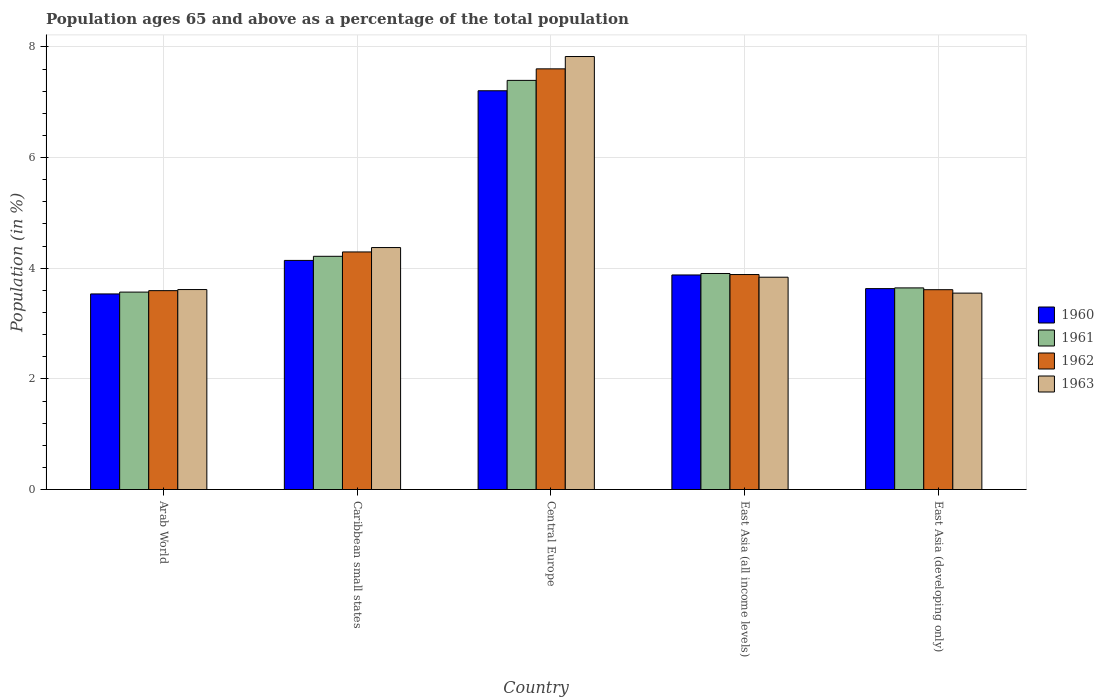How many groups of bars are there?
Keep it short and to the point. 5. Are the number of bars per tick equal to the number of legend labels?
Your response must be concise. Yes. Are the number of bars on each tick of the X-axis equal?
Provide a short and direct response. Yes. What is the label of the 3rd group of bars from the left?
Give a very brief answer. Central Europe. In how many cases, is the number of bars for a given country not equal to the number of legend labels?
Keep it short and to the point. 0. What is the percentage of the population ages 65 and above in 1960 in Central Europe?
Provide a succinct answer. 7.21. Across all countries, what is the maximum percentage of the population ages 65 and above in 1962?
Keep it short and to the point. 7.6. Across all countries, what is the minimum percentage of the population ages 65 and above in 1960?
Your answer should be very brief. 3.54. In which country was the percentage of the population ages 65 and above in 1961 maximum?
Provide a succinct answer. Central Europe. In which country was the percentage of the population ages 65 and above in 1963 minimum?
Offer a terse response. East Asia (developing only). What is the total percentage of the population ages 65 and above in 1962 in the graph?
Your answer should be compact. 22.99. What is the difference between the percentage of the population ages 65 and above in 1963 in Central Europe and that in East Asia (developing only)?
Ensure brevity in your answer.  4.28. What is the difference between the percentage of the population ages 65 and above in 1963 in East Asia (all income levels) and the percentage of the population ages 65 and above in 1960 in East Asia (developing only)?
Make the answer very short. 0.21. What is the average percentage of the population ages 65 and above in 1960 per country?
Your response must be concise. 4.48. What is the difference between the percentage of the population ages 65 and above of/in 1963 and percentage of the population ages 65 and above of/in 1961 in Central Europe?
Offer a very short reply. 0.43. What is the ratio of the percentage of the population ages 65 and above in 1960 in Arab World to that in East Asia (developing only)?
Give a very brief answer. 0.97. Is the percentage of the population ages 65 and above in 1963 in Caribbean small states less than that in East Asia (developing only)?
Provide a succinct answer. No. Is the difference between the percentage of the population ages 65 and above in 1963 in Caribbean small states and East Asia (developing only) greater than the difference between the percentage of the population ages 65 and above in 1961 in Caribbean small states and East Asia (developing only)?
Provide a short and direct response. Yes. What is the difference between the highest and the second highest percentage of the population ages 65 and above in 1961?
Ensure brevity in your answer.  -0.31. What is the difference between the highest and the lowest percentage of the population ages 65 and above in 1961?
Your answer should be very brief. 3.83. In how many countries, is the percentage of the population ages 65 and above in 1961 greater than the average percentage of the population ages 65 and above in 1961 taken over all countries?
Your answer should be compact. 1. Is the sum of the percentage of the population ages 65 and above in 1961 in Central Europe and East Asia (developing only) greater than the maximum percentage of the population ages 65 and above in 1963 across all countries?
Your answer should be compact. Yes. What does the 4th bar from the left in East Asia (developing only) represents?
Provide a short and direct response. 1963. What does the 3rd bar from the right in Arab World represents?
Give a very brief answer. 1961. Are all the bars in the graph horizontal?
Offer a very short reply. No. How many countries are there in the graph?
Ensure brevity in your answer.  5. What is the difference between two consecutive major ticks on the Y-axis?
Offer a terse response. 2. Are the values on the major ticks of Y-axis written in scientific E-notation?
Ensure brevity in your answer.  No. Where does the legend appear in the graph?
Your response must be concise. Center right. How many legend labels are there?
Your answer should be very brief. 4. What is the title of the graph?
Your answer should be very brief. Population ages 65 and above as a percentage of the total population. Does "2010" appear as one of the legend labels in the graph?
Your response must be concise. No. What is the label or title of the X-axis?
Offer a very short reply. Country. What is the Population (in %) of 1960 in Arab World?
Keep it short and to the point. 3.54. What is the Population (in %) in 1961 in Arab World?
Make the answer very short. 3.57. What is the Population (in %) in 1962 in Arab World?
Offer a terse response. 3.59. What is the Population (in %) of 1963 in Arab World?
Your answer should be compact. 3.61. What is the Population (in %) of 1960 in Caribbean small states?
Make the answer very short. 4.14. What is the Population (in %) of 1961 in Caribbean small states?
Make the answer very short. 4.22. What is the Population (in %) of 1962 in Caribbean small states?
Provide a succinct answer. 4.29. What is the Population (in %) in 1963 in Caribbean small states?
Your answer should be compact. 4.37. What is the Population (in %) in 1960 in Central Europe?
Your response must be concise. 7.21. What is the Population (in %) of 1961 in Central Europe?
Your answer should be compact. 7.4. What is the Population (in %) in 1962 in Central Europe?
Your response must be concise. 7.6. What is the Population (in %) in 1963 in Central Europe?
Your response must be concise. 7.83. What is the Population (in %) in 1960 in East Asia (all income levels)?
Provide a succinct answer. 3.88. What is the Population (in %) in 1961 in East Asia (all income levels)?
Provide a succinct answer. 3.9. What is the Population (in %) of 1962 in East Asia (all income levels)?
Your response must be concise. 3.89. What is the Population (in %) of 1963 in East Asia (all income levels)?
Provide a succinct answer. 3.84. What is the Population (in %) in 1960 in East Asia (developing only)?
Keep it short and to the point. 3.63. What is the Population (in %) in 1961 in East Asia (developing only)?
Make the answer very short. 3.64. What is the Population (in %) of 1962 in East Asia (developing only)?
Offer a very short reply. 3.61. What is the Population (in %) of 1963 in East Asia (developing only)?
Your answer should be compact. 3.55. Across all countries, what is the maximum Population (in %) of 1960?
Make the answer very short. 7.21. Across all countries, what is the maximum Population (in %) in 1961?
Provide a short and direct response. 7.4. Across all countries, what is the maximum Population (in %) in 1962?
Your answer should be very brief. 7.6. Across all countries, what is the maximum Population (in %) in 1963?
Offer a terse response. 7.83. Across all countries, what is the minimum Population (in %) of 1960?
Your answer should be very brief. 3.54. Across all countries, what is the minimum Population (in %) in 1961?
Make the answer very short. 3.57. Across all countries, what is the minimum Population (in %) of 1962?
Your answer should be compact. 3.59. Across all countries, what is the minimum Population (in %) in 1963?
Your response must be concise. 3.55. What is the total Population (in %) in 1960 in the graph?
Provide a succinct answer. 22.39. What is the total Population (in %) in 1961 in the graph?
Keep it short and to the point. 22.73. What is the total Population (in %) of 1962 in the graph?
Make the answer very short. 22.99. What is the total Population (in %) of 1963 in the graph?
Give a very brief answer. 23.2. What is the difference between the Population (in %) of 1960 in Arab World and that in Caribbean small states?
Offer a very short reply. -0.61. What is the difference between the Population (in %) in 1961 in Arab World and that in Caribbean small states?
Give a very brief answer. -0.65. What is the difference between the Population (in %) of 1962 in Arab World and that in Caribbean small states?
Offer a very short reply. -0.7. What is the difference between the Population (in %) in 1963 in Arab World and that in Caribbean small states?
Your answer should be very brief. -0.76. What is the difference between the Population (in %) in 1960 in Arab World and that in Central Europe?
Offer a terse response. -3.67. What is the difference between the Population (in %) in 1961 in Arab World and that in Central Europe?
Offer a terse response. -3.83. What is the difference between the Population (in %) in 1962 in Arab World and that in Central Europe?
Make the answer very short. -4.01. What is the difference between the Population (in %) in 1963 in Arab World and that in Central Europe?
Your response must be concise. -4.21. What is the difference between the Population (in %) of 1960 in Arab World and that in East Asia (all income levels)?
Offer a terse response. -0.34. What is the difference between the Population (in %) of 1961 in Arab World and that in East Asia (all income levels)?
Keep it short and to the point. -0.34. What is the difference between the Population (in %) in 1962 in Arab World and that in East Asia (all income levels)?
Provide a succinct answer. -0.29. What is the difference between the Population (in %) of 1963 in Arab World and that in East Asia (all income levels)?
Ensure brevity in your answer.  -0.22. What is the difference between the Population (in %) of 1960 in Arab World and that in East Asia (developing only)?
Ensure brevity in your answer.  -0.1. What is the difference between the Population (in %) in 1961 in Arab World and that in East Asia (developing only)?
Provide a succinct answer. -0.08. What is the difference between the Population (in %) in 1962 in Arab World and that in East Asia (developing only)?
Give a very brief answer. -0.02. What is the difference between the Population (in %) in 1963 in Arab World and that in East Asia (developing only)?
Offer a very short reply. 0.06. What is the difference between the Population (in %) in 1960 in Caribbean small states and that in Central Europe?
Your response must be concise. -3.07. What is the difference between the Population (in %) of 1961 in Caribbean small states and that in Central Europe?
Provide a short and direct response. -3.18. What is the difference between the Population (in %) of 1962 in Caribbean small states and that in Central Europe?
Provide a short and direct response. -3.31. What is the difference between the Population (in %) in 1963 in Caribbean small states and that in Central Europe?
Offer a terse response. -3.45. What is the difference between the Population (in %) of 1960 in Caribbean small states and that in East Asia (all income levels)?
Provide a succinct answer. 0.26. What is the difference between the Population (in %) of 1961 in Caribbean small states and that in East Asia (all income levels)?
Your answer should be compact. 0.31. What is the difference between the Population (in %) of 1962 in Caribbean small states and that in East Asia (all income levels)?
Provide a short and direct response. 0.41. What is the difference between the Population (in %) in 1963 in Caribbean small states and that in East Asia (all income levels)?
Your answer should be compact. 0.54. What is the difference between the Population (in %) in 1960 in Caribbean small states and that in East Asia (developing only)?
Provide a succinct answer. 0.51. What is the difference between the Population (in %) of 1961 in Caribbean small states and that in East Asia (developing only)?
Keep it short and to the point. 0.57. What is the difference between the Population (in %) of 1962 in Caribbean small states and that in East Asia (developing only)?
Provide a short and direct response. 0.68. What is the difference between the Population (in %) in 1963 in Caribbean small states and that in East Asia (developing only)?
Provide a short and direct response. 0.82. What is the difference between the Population (in %) of 1960 in Central Europe and that in East Asia (all income levels)?
Provide a succinct answer. 3.33. What is the difference between the Population (in %) in 1961 in Central Europe and that in East Asia (all income levels)?
Your response must be concise. 3.49. What is the difference between the Population (in %) in 1962 in Central Europe and that in East Asia (all income levels)?
Give a very brief answer. 3.72. What is the difference between the Population (in %) of 1963 in Central Europe and that in East Asia (all income levels)?
Provide a succinct answer. 3.99. What is the difference between the Population (in %) in 1960 in Central Europe and that in East Asia (developing only)?
Keep it short and to the point. 3.58. What is the difference between the Population (in %) of 1961 in Central Europe and that in East Asia (developing only)?
Offer a very short reply. 3.75. What is the difference between the Population (in %) in 1962 in Central Europe and that in East Asia (developing only)?
Provide a succinct answer. 3.99. What is the difference between the Population (in %) of 1963 in Central Europe and that in East Asia (developing only)?
Your response must be concise. 4.28. What is the difference between the Population (in %) of 1960 in East Asia (all income levels) and that in East Asia (developing only)?
Offer a very short reply. 0.25. What is the difference between the Population (in %) of 1961 in East Asia (all income levels) and that in East Asia (developing only)?
Your answer should be very brief. 0.26. What is the difference between the Population (in %) of 1962 in East Asia (all income levels) and that in East Asia (developing only)?
Ensure brevity in your answer.  0.27. What is the difference between the Population (in %) of 1963 in East Asia (all income levels) and that in East Asia (developing only)?
Provide a short and direct response. 0.29. What is the difference between the Population (in %) of 1960 in Arab World and the Population (in %) of 1961 in Caribbean small states?
Your answer should be compact. -0.68. What is the difference between the Population (in %) in 1960 in Arab World and the Population (in %) in 1962 in Caribbean small states?
Offer a terse response. -0.76. What is the difference between the Population (in %) in 1960 in Arab World and the Population (in %) in 1963 in Caribbean small states?
Your answer should be very brief. -0.84. What is the difference between the Population (in %) in 1961 in Arab World and the Population (in %) in 1962 in Caribbean small states?
Provide a succinct answer. -0.73. What is the difference between the Population (in %) of 1961 in Arab World and the Population (in %) of 1963 in Caribbean small states?
Your answer should be very brief. -0.81. What is the difference between the Population (in %) in 1962 in Arab World and the Population (in %) in 1963 in Caribbean small states?
Your answer should be very brief. -0.78. What is the difference between the Population (in %) in 1960 in Arab World and the Population (in %) in 1961 in Central Europe?
Provide a short and direct response. -3.86. What is the difference between the Population (in %) in 1960 in Arab World and the Population (in %) in 1962 in Central Europe?
Provide a short and direct response. -4.07. What is the difference between the Population (in %) in 1960 in Arab World and the Population (in %) in 1963 in Central Europe?
Provide a succinct answer. -4.29. What is the difference between the Population (in %) of 1961 in Arab World and the Population (in %) of 1962 in Central Europe?
Offer a terse response. -4.04. What is the difference between the Population (in %) of 1961 in Arab World and the Population (in %) of 1963 in Central Europe?
Give a very brief answer. -4.26. What is the difference between the Population (in %) of 1962 in Arab World and the Population (in %) of 1963 in Central Europe?
Offer a terse response. -4.23. What is the difference between the Population (in %) in 1960 in Arab World and the Population (in %) in 1961 in East Asia (all income levels)?
Ensure brevity in your answer.  -0.37. What is the difference between the Population (in %) in 1960 in Arab World and the Population (in %) in 1962 in East Asia (all income levels)?
Make the answer very short. -0.35. What is the difference between the Population (in %) of 1960 in Arab World and the Population (in %) of 1963 in East Asia (all income levels)?
Your answer should be compact. -0.3. What is the difference between the Population (in %) of 1961 in Arab World and the Population (in %) of 1962 in East Asia (all income levels)?
Provide a short and direct response. -0.32. What is the difference between the Population (in %) in 1961 in Arab World and the Population (in %) in 1963 in East Asia (all income levels)?
Offer a very short reply. -0.27. What is the difference between the Population (in %) in 1962 in Arab World and the Population (in %) in 1963 in East Asia (all income levels)?
Offer a very short reply. -0.24. What is the difference between the Population (in %) in 1960 in Arab World and the Population (in %) in 1961 in East Asia (developing only)?
Your answer should be very brief. -0.11. What is the difference between the Population (in %) in 1960 in Arab World and the Population (in %) in 1962 in East Asia (developing only)?
Provide a succinct answer. -0.08. What is the difference between the Population (in %) in 1960 in Arab World and the Population (in %) in 1963 in East Asia (developing only)?
Provide a short and direct response. -0.01. What is the difference between the Population (in %) in 1961 in Arab World and the Population (in %) in 1962 in East Asia (developing only)?
Offer a very short reply. -0.04. What is the difference between the Population (in %) of 1961 in Arab World and the Population (in %) of 1963 in East Asia (developing only)?
Provide a short and direct response. 0.02. What is the difference between the Population (in %) of 1962 in Arab World and the Population (in %) of 1963 in East Asia (developing only)?
Make the answer very short. 0.04. What is the difference between the Population (in %) in 1960 in Caribbean small states and the Population (in %) in 1961 in Central Europe?
Keep it short and to the point. -3.25. What is the difference between the Population (in %) in 1960 in Caribbean small states and the Population (in %) in 1962 in Central Europe?
Your answer should be compact. -3.46. What is the difference between the Population (in %) of 1960 in Caribbean small states and the Population (in %) of 1963 in Central Europe?
Offer a terse response. -3.69. What is the difference between the Population (in %) in 1961 in Caribbean small states and the Population (in %) in 1962 in Central Europe?
Give a very brief answer. -3.39. What is the difference between the Population (in %) in 1961 in Caribbean small states and the Population (in %) in 1963 in Central Europe?
Your answer should be very brief. -3.61. What is the difference between the Population (in %) in 1962 in Caribbean small states and the Population (in %) in 1963 in Central Europe?
Keep it short and to the point. -3.53. What is the difference between the Population (in %) of 1960 in Caribbean small states and the Population (in %) of 1961 in East Asia (all income levels)?
Your answer should be very brief. 0.24. What is the difference between the Population (in %) in 1960 in Caribbean small states and the Population (in %) in 1962 in East Asia (all income levels)?
Give a very brief answer. 0.26. What is the difference between the Population (in %) in 1960 in Caribbean small states and the Population (in %) in 1963 in East Asia (all income levels)?
Ensure brevity in your answer.  0.3. What is the difference between the Population (in %) of 1961 in Caribbean small states and the Population (in %) of 1962 in East Asia (all income levels)?
Offer a terse response. 0.33. What is the difference between the Population (in %) of 1961 in Caribbean small states and the Population (in %) of 1963 in East Asia (all income levels)?
Your answer should be very brief. 0.38. What is the difference between the Population (in %) in 1962 in Caribbean small states and the Population (in %) in 1963 in East Asia (all income levels)?
Provide a short and direct response. 0.46. What is the difference between the Population (in %) in 1960 in Caribbean small states and the Population (in %) in 1961 in East Asia (developing only)?
Keep it short and to the point. 0.5. What is the difference between the Population (in %) in 1960 in Caribbean small states and the Population (in %) in 1962 in East Asia (developing only)?
Your response must be concise. 0.53. What is the difference between the Population (in %) in 1960 in Caribbean small states and the Population (in %) in 1963 in East Asia (developing only)?
Give a very brief answer. 0.59. What is the difference between the Population (in %) in 1961 in Caribbean small states and the Population (in %) in 1962 in East Asia (developing only)?
Provide a short and direct response. 0.6. What is the difference between the Population (in %) of 1961 in Caribbean small states and the Population (in %) of 1963 in East Asia (developing only)?
Offer a very short reply. 0.67. What is the difference between the Population (in %) of 1962 in Caribbean small states and the Population (in %) of 1963 in East Asia (developing only)?
Provide a short and direct response. 0.74. What is the difference between the Population (in %) of 1960 in Central Europe and the Population (in %) of 1961 in East Asia (all income levels)?
Keep it short and to the point. 3.3. What is the difference between the Population (in %) in 1960 in Central Europe and the Population (in %) in 1962 in East Asia (all income levels)?
Offer a terse response. 3.32. What is the difference between the Population (in %) of 1960 in Central Europe and the Population (in %) of 1963 in East Asia (all income levels)?
Provide a short and direct response. 3.37. What is the difference between the Population (in %) in 1961 in Central Europe and the Population (in %) in 1962 in East Asia (all income levels)?
Ensure brevity in your answer.  3.51. What is the difference between the Population (in %) in 1961 in Central Europe and the Population (in %) in 1963 in East Asia (all income levels)?
Your answer should be very brief. 3.56. What is the difference between the Population (in %) of 1962 in Central Europe and the Population (in %) of 1963 in East Asia (all income levels)?
Offer a terse response. 3.77. What is the difference between the Population (in %) in 1960 in Central Europe and the Population (in %) in 1961 in East Asia (developing only)?
Keep it short and to the point. 3.56. What is the difference between the Population (in %) of 1960 in Central Europe and the Population (in %) of 1962 in East Asia (developing only)?
Provide a short and direct response. 3.6. What is the difference between the Population (in %) of 1960 in Central Europe and the Population (in %) of 1963 in East Asia (developing only)?
Ensure brevity in your answer.  3.66. What is the difference between the Population (in %) in 1961 in Central Europe and the Population (in %) in 1962 in East Asia (developing only)?
Make the answer very short. 3.78. What is the difference between the Population (in %) of 1961 in Central Europe and the Population (in %) of 1963 in East Asia (developing only)?
Offer a terse response. 3.85. What is the difference between the Population (in %) in 1962 in Central Europe and the Population (in %) in 1963 in East Asia (developing only)?
Provide a succinct answer. 4.05. What is the difference between the Population (in %) in 1960 in East Asia (all income levels) and the Population (in %) in 1961 in East Asia (developing only)?
Ensure brevity in your answer.  0.23. What is the difference between the Population (in %) of 1960 in East Asia (all income levels) and the Population (in %) of 1962 in East Asia (developing only)?
Provide a short and direct response. 0.27. What is the difference between the Population (in %) of 1960 in East Asia (all income levels) and the Population (in %) of 1963 in East Asia (developing only)?
Provide a short and direct response. 0.33. What is the difference between the Population (in %) in 1961 in East Asia (all income levels) and the Population (in %) in 1962 in East Asia (developing only)?
Give a very brief answer. 0.29. What is the difference between the Population (in %) in 1961 in East Asia (all income levels) and the Population (in %) in 1963 in East Asia (developing only)?
Your answer should be compact. 0.35. What is the difference between the Population (in %) of 1962 in East Asia (all income levels) and the Population (in %) of 1963 in East Asia (developing only)?
Offer a very short reply. 0.34. What is the average Population (in %) of 1960 per country?
Give a very brief answer. 4.48. What is the average Population (in %) of 1961 per country?
Provide a succinct answer. 4.55. What is the average Population (in %) of 1962 per country?
Ensure brevity in your answer.  4.6. What is the average Population (in %) in 1963 per country?
Offer a terse response. 4.64. What is the difference between the Population (in %) of 1960 and Population (in %) of 1961 in Arab World?
Offer a very short reply. -0.03. What is the difference between the Population (in %) of 1960 and Population (in %) of 1962 in Arab World?
Give a very brief answer. -0.06. What is the difference between the Population (in %) of 1960 and Population (in %) of 1963 in Arab World?
Provide a succinct answer. -0.08. What is the difference between the Population (in %) of 1961 and Population (in %) of 1962 in Arab World?
Your answer should be compact. -0.03. What is the difference between the Population (in %) in 1961 and Population (in %) in 1963 in Arab World?
Your answer should be compact. -0.05. What is the difference between the Population (in %) in 1962 and Population (in %) in 1963 in Arab World?
Provide a short and direct response. -0.02. What is the difference between the Population (in %) in 1960 and Population (in %) in 1961 in Caribbean small states?
Your answer should be compact. -0.07. What is the difference between the Population (in %) of 1960 and Population (in %) of 1962 in Caribbean small states?
Your answer should be very brief. -0.15. What is the difference between the Population (in %) in 1960 and Population (in %) in 1963 in Caribbean small states?
Offer a very short reply. -0.23. What is the difference between the Population (in %) of 1961 and Population (in %) of 1962 in Caribbean small states?
Make the answer very short. -0.08. What is the difference between the Population (in %) in 1961 and Population (in %) in 1963 in Caribbean small states?
Your answer should be compact. -0.16. What is the difference between the Population (in %) in 1962 and Population (in %) in 1963 in Caribbean small states?
Ensure brevity in your answer.  -0.08. What is the difference between the Population (in %) of 1960 and Population (in %) of 1961 in Central Europe?
Your response must be concise. -0.19. What is the difference between the Population (in %) in 1960 and Population (in %) in 1962 in Central Europe?
Offer a very short reply. -0.4. What is the difference between the Population (in %) in 1960 and Population (in %) in 1963 in Central Europe?
Your answer should be very brief. -0.62. What is the difference between the Population (in %) in 1961 and Population (in %) in 1962 in Central Europe?
Provide a succinct answer. -0.21. What is the difference between the Population (in %) of 1961 and Population (in %) of 1963 in Central Europe?
Your answer should be very brief. -0.43. What is the difference between the Population (in %) in 1962 and Population (in %) in 1963 in Central Europe?
Make the answer very short. -0.22. What is the difference between the Population (in %) of 1960 and Population (in %) of 1961 in East Asia (all income levels)?
Offer a very short reply. -0.03. What is the difference between the Population (in %) of 1960 and Population (in %) of 1962 in East Asia (all income levels)?
Offer a terse response. -0.01. What is the difference between the Population (in %) of 1960 and Population (in %) of 1963 in East Asia (all income levels)?
Offer a terse response. 0.04. What is the difference between the Population (in %) of 1961 and Population (in %) of 1962 in East Asia (all income levels)?
Your answer should be very brief. 0.02. What is the difference between the Population (in %) of 1961 and Population (in %) of 1963 in East Asia (all income levels)?
Offer a very short reply. 0.07. What is the difference between the Population (in %) of 1962 and Population (in %) of 1963 in East Asia (all income levels)?
Your answer should be compact. 0.05. What is the difference between the Population (in %) of 1960 and Population (in %) of 1961 in East Asia (developing only)?
Give a very brief answer. -0.01. What is the difference between the Population (in %) in 1960 and Population (in %) in 1962 in East Asia (developing only)?
Provide a succinct answer. 0.02. What is the difference between the Population (in %) in 1960 and Population (in %) in 1963 in East Asia (developing only)?
Ensure brevity in your answer.  0.08. What is the difference between the Population (in %) of 1961 and Population (in %) of 1962 in East Asia (developing only)?
Your response must be concise. 0.03. What is the difference between the Population (in %) of 1961 and Population (in %) of 1963 in East Asia (developing only)?
Your answer should be compact. 0.09. What is the difference between the Population (in %) in 1962 and Population (in %) in 1963 in East Asia (developing only)?
Your response must be concise. 0.06. What is the ratio of the Population (in %) of 1960 in Arab World to that in Caribbean small states?
Give a very brief answer. 0.85. What is the ratio of the Population (in %) in 1961 in Arab World to that in Caribbean small states?
Make the answer very short. 0.85. What is the ratio of the Population (in %) in 1962 in Arab World to that in Caribbean small states?
Keep it short and to the point. 0.84. What is the ratio of the Population (in %) of 1963 in Arab World to that in Caribbean small states?
Provide a succinct answer. 0.83. What is the ratio of the Population (in %) of 1960 in Arab World to that in Central Europe?
Your response must be concise. 0.49. What is the ratio of the Population (in %) of 1961 in Arab World to that in Central Europe?
Your answer should be compact. 0.48. What is the ratio of the Population (in %) of 1962 in Arab World to that in Central Europe?
Offer a very short reply. 0.47. What is the ratio of the Population (in %) of 1963 in Arab World to that in Central Europe?
Your answer should be very brief. 0.46. What is the ratio of the Population (in %) of 1960 in Arab World to that in East Asia (all income levels)?
Keep it short and to the point. 0.91. What is the ratio of the Population (in %) in 1961 in Arab World to that in East Asia (all income levels)?
Make the answer very short. 0.91. What is the ratio of the Population (in %) in 1962 in Arab World to that in East Asia (all income levels)?
Provide a short and direct response. 0.93. What is the ratio of the Population (in %) of 1963 in Arab World to that in East Asia (all income levels)?
Give a very brief answer. 0.94. What is the ratio of the Population (in %) of 1960 in Arab World to that in East Asia (developing only)?
Your answer should be very brief. 0.97. What is the ratio of the Population (in %) in 1961 in Arab World to that in East Asia (developing only)?
Your answer should be very brief. 0.98. What is the ratio of the Population (in %) of 1963 in Arab World to that in East Asia (developing only)?
Your response must be concise. 1.02. What is the ratio of the Population (in %) of 1960 in Caribbean small states to that in Central Europe?
Offer a very short reply. 0.57. What is the ratio of the Population (in %) of 1961 in Caribbean small states to that in Central Europe?
Ensure brevity in your answer.  0.57. What is the ratio of the Population (in %) of 1962 in Caribbean small states to that in Central Europe?
Offer a very short reply. 0.56. What is the ratio of the Population (in %) of 1963 in Caribbean small states to that in Central Europe?
Provide a short and direct response. 0.56. What is the ratio of the Population (in %) of 1960 in Caribbean small states to that in East Asia (all income levels)?
Your answer should be compact. 1.07. What is the ratio of the Population (in %) in 1961 in Caribbean small states to that in East Asia (all income levels)?
Your answer should be very brief. 1.08. What is the ratio of the Population (in %) in 1962 in Caribbean small states to that in East Asia (all income levels)?
Keep it short and to the point. 1.11. What is the ratio of the Population (in %) in 1963 in Caribbean small states to that in East Asia (all income levels)?
Provide a succinct answer. 1.14. What is the ratio of the Population (in %) of 1960 in Caribbean small states to that in East Asia (developing only)?
Make the answer very short. 1.14. What is the ratio of the Population (in %) in 1961 in Caribbean small states to that in East Asia (developing only)?
Your response must be concise. 1.16. What is the ratio of the Population (in %) in 1962 in Caribbean small states to that in East Asia (developing only)?
Make the answer very short. 1.19. What is the ratio of the Population (in %) of 1963 in Caribbean small states to that in East Asia (developing only)?
Provide a short and direct response. 1.23. What is the ratio of the Population (in %) of 1960 in Central Europe to that in East Asia (all income levels)?
Your answer should be compact. 1.86. What is the ratio of the Population (in %) in 1961 in Central Europe to that in East Asia (all income levels)?
Your answer should be very brief. 1.89. What is the ratio of the Population (in %) of 1962 in Central Europe to that in East Asia (all income levels)?
Your answer should be very brief. 1.96. What is the ratio of the Population (in %) of 1963 in Central Europe to that in East Asia (all income levels)?
Your response must be concise. 2.04. What is the ratio of the Population (in %) of 1960 in Central Europe to that in East Asia (developing only)?
Your answer should be very brief. 1.98. What is the ratio of the Population (in %) in 1961 in Central Europe to that in East Asia (developing only)?
Your answer should be very brief. 2.03. What is the ratio of the Population (in %) of 1962 in Central Europe to that in East Asia (developing only)?
Ensure brevity in your answer.  2.11. What is the ratio of the Population (in %) of 1963 in Central Europe to that in East Asia (developing only)?
Provide a short and direct response. 2.2. What is the ratio of the Population (in %) of 1960 in East Asia (all income levels) to that in East Asia (developing only)?
Your response must be concise. 1.07. What is the ratio of the Population (in %) in 1961 in East Asia (all income levels) to that in East Asia (developing only)?
Offer a very short reply. 1.07. What is the ratio of the Population (in %) of 1962 in East Asia (all income levels) to that in East Asia (developing only)?
Give a very brief answer. 1.08. What is the ratio of the Population (in %) in 1963 in East Asia (all income levels) to that in East Asia (developing only)?
Provide a succinct answer. 1.08. What is the difference between the highest and the second highest Population (in %) of 1960?
Provide a short and direct response. 3.07. What is the difference between the highest and the second highest Population (in %) of 1961?
Provide a short and direct response. 3.18. What is the difference between the highest and the second highest Population (in %) of 1962?
Your response must be concise. 3.31. What is the difference between the highest and the second highest Population (in %) in 1963?
Offer a terse response. 3.45. What is the difference between the highest and the lowest Population (in %) in 1960?
Provide a short and direct response. 3.67. What is the difference between the highest and the lowest Population (in %) of 1961?
Give a very brief answer. 3.83. What is the difference between the highest and the lowest Population (in %) in 1962?
Your answer should be compact. 4.01. What is the difference between the highest and the lowest Population (in %) in 1963?
Your response must be concise. 4.28. 